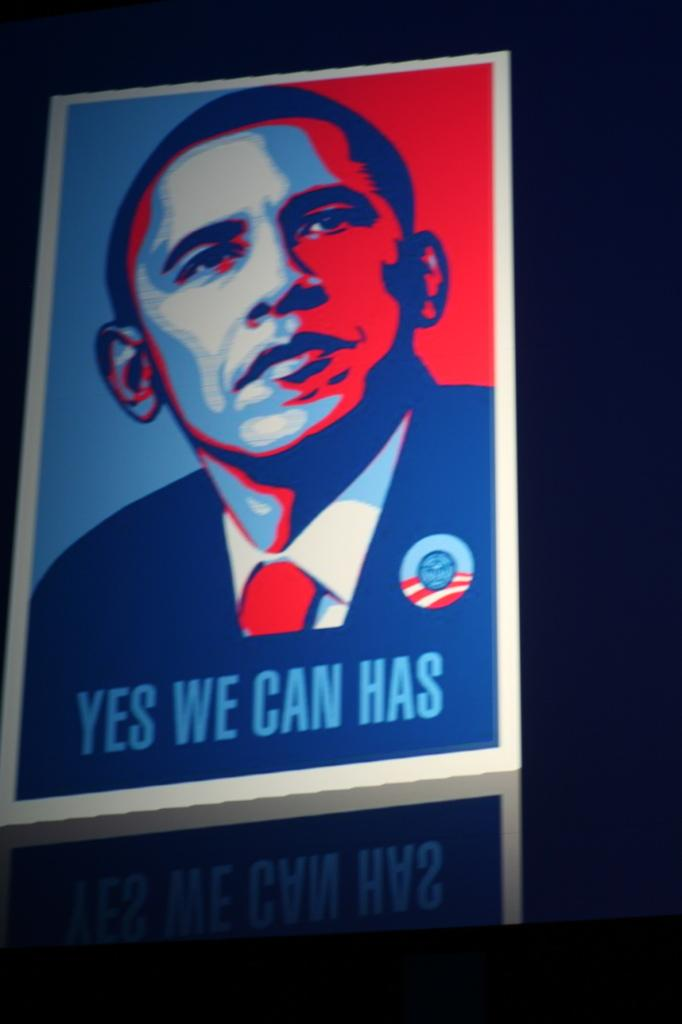<image>
Provide a brief description of the given image. A yes we can has poster of the red and blue colored image of Obama. 